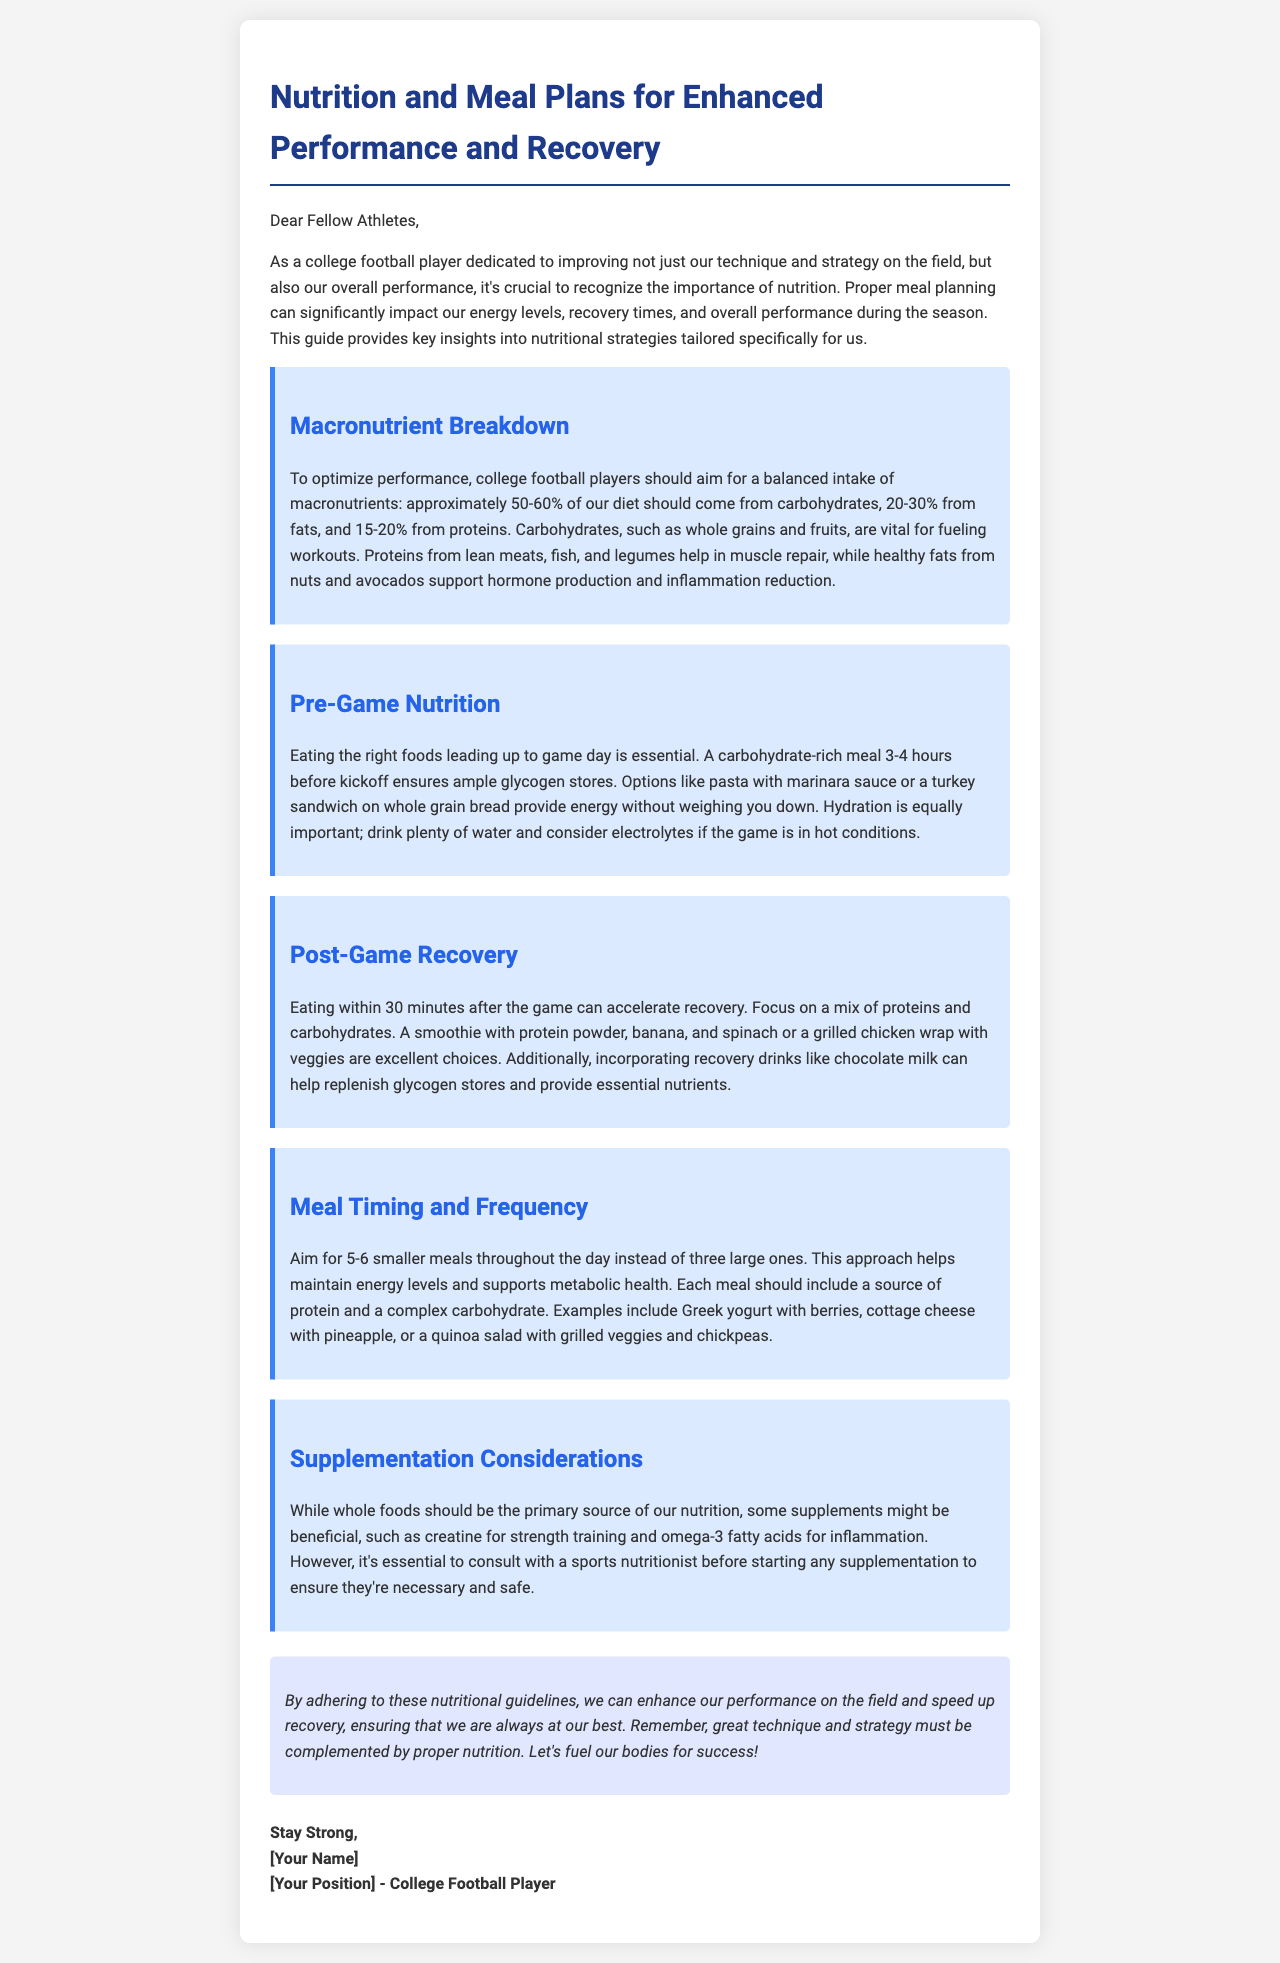What is the main purpose of the letter? The letter aims to provide guidance on nutrition and meal plans for college football players to enhance performance and recovery.
Answer: enhance performance and recovery What percentage of the diet should come from carbohydrates? The document specifies that approximately 50-60% of the diet should come from carbohydrates for optimal performance.
Answer: 50-60% What is an ideal pre-game meal option mentioned in the letter? The letter suggests pasta with marinara sauce or a turkey sandwich on whole grain bread as suitable pre-game meal options.
Answer: pasta with marinara sauce When should athletes eat post-game for optimal recovery? Athletes should eat within 30 minutes after the game to accelerate recovery according to the document.
Answer: 30 minutes What is a recommended snack idea for a small meal? The document provides examples of Greek yogurt with berries or cottage cheese with pineapple as small meal ideas.
Answer: Greek yogurt with berries What is the role of protein in a college football player's diet? Protein is important for muscle repair, as stated in the document.
Answer: muscle repair What supplement is mentioned as potentially beneficial for strength training? The letter mentions creatine as a beneficial supplement for strength training.
Answer: creatine How many meals does the document recommend throughout the day? The letter recommends aiming for 5-6 smaller meals throughout the day.
Answer: 5-6 Who is the author of the letter? The author identifies themselves as a college football player in the letter.
Answer: college football player 